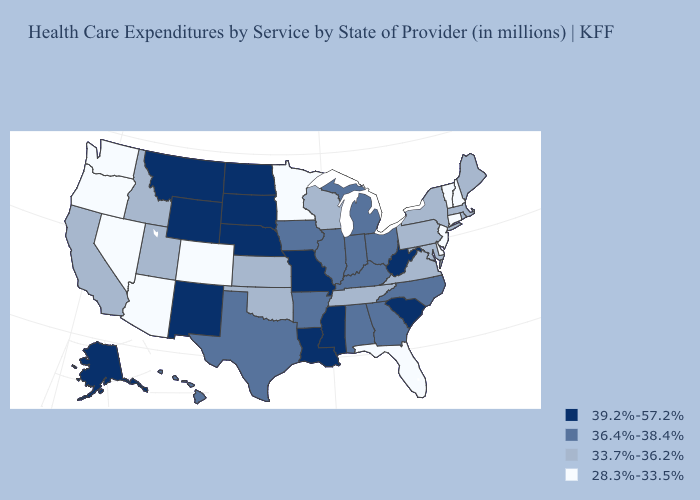Name the states that have a value in the range 33.7%-36.2%?
Short answer required. California, Idaho, Kansas, Maine, Maryland, Massachusetts, New York, Oklahoma, Pennsylvania, Rhode Island, Tennessee, Utah, Virginia, Wisconsin. Does Delaware have the highest value in the USA?
Be succinct. No. Does Tennessee have a lower value than Delaware?
Short answer required. No. Name the states that have a value in the range 36.4%-38.4%?
Short answer required. Alabama, Arkansas, Georgia, Hawaii, Illinois, Indiana, Iowa, Kentucky, Michigan, North Carolina, Ohio, Texas. What is the highest value in the MidWest ?
Quick response, please. 39.2%-57.2%. Does the first symbol in the legend represent the smallest category?
Concise answer only. No. Does the first symbol in the legend represent the smallest category?
Keep it brief. No. Name the states that have a value in the range 36.4%-38.4%?
Be succinct. Alabama, Arkansas, Georgia, Hawaii, Illinois, Indiana, Iowa, Kentucky, Michigan, North Carolina, Ohio, Texas. Does Idaho have the lowest value in the West?
Give a very brief answer. No. Does Kansas have the highest value in the MidWest?
Give a very brief answer. No. Name the states that have a value in the range 36.4%-38.4%?
Quick response, please. Alabama, Arkansas, Georgia, Hawaii, Illinois, Indiana, Iowa, Kentucky, Michigan, North Carolina, Ohio, Texas. What is the highest value in the USA?
Give a very brief answer. 39.2%-57.2%. Name the states that have a value in the range 39.2%-57.2%?
Answer briefly. Alaska, Louisiana, Mississippi, Missouri, Montana, Nebraska, New Mexico, North Dakota, South Carolina, South Dakota, West Virginia, Wyoming. How many symbols are there in the legend?
Answer briefly. 4. What is the value of Mississippi?
Be succinct. 39.2%-57.2%. 